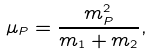<formula> <loc_0><loc_0><loc_500><loc_500>\mu _ { P } = \frac { m _ { P } ^ { 2 } } { m _ { 1 } + m _ { 2 } } ,</formula> 